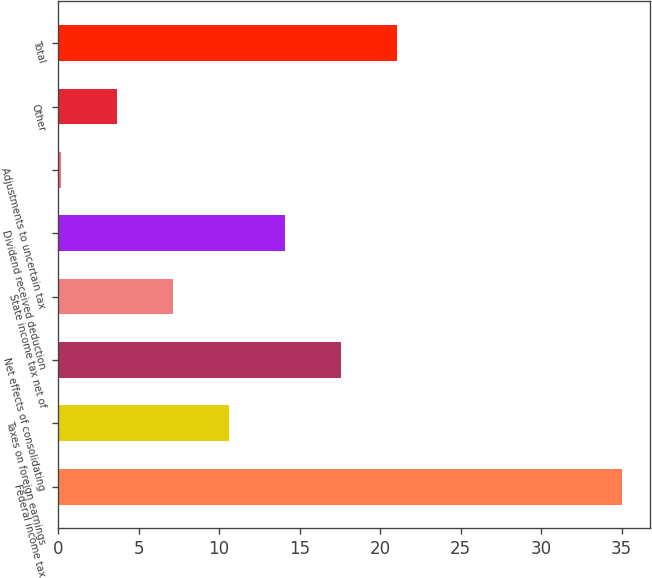Convert chart. <chart><loc_0><loc_0><loc_500><loc_500><bar_chart><fcel>Federal income tax<fcel>Taxes on foreign earnings<fcel>Net effects of consolidating<fcel>State income tax net of<fcel>Dividend received deduction<fcel>Adjustments to uncertain tax<fcel>Other<fcel>Total<nl><fcel>35<fcel>10.64<fcel>17.6<fcel>7.16<fcel>14.12<fcel>0.2<fcel>3.68<fcel>21.08<nl></chart> 